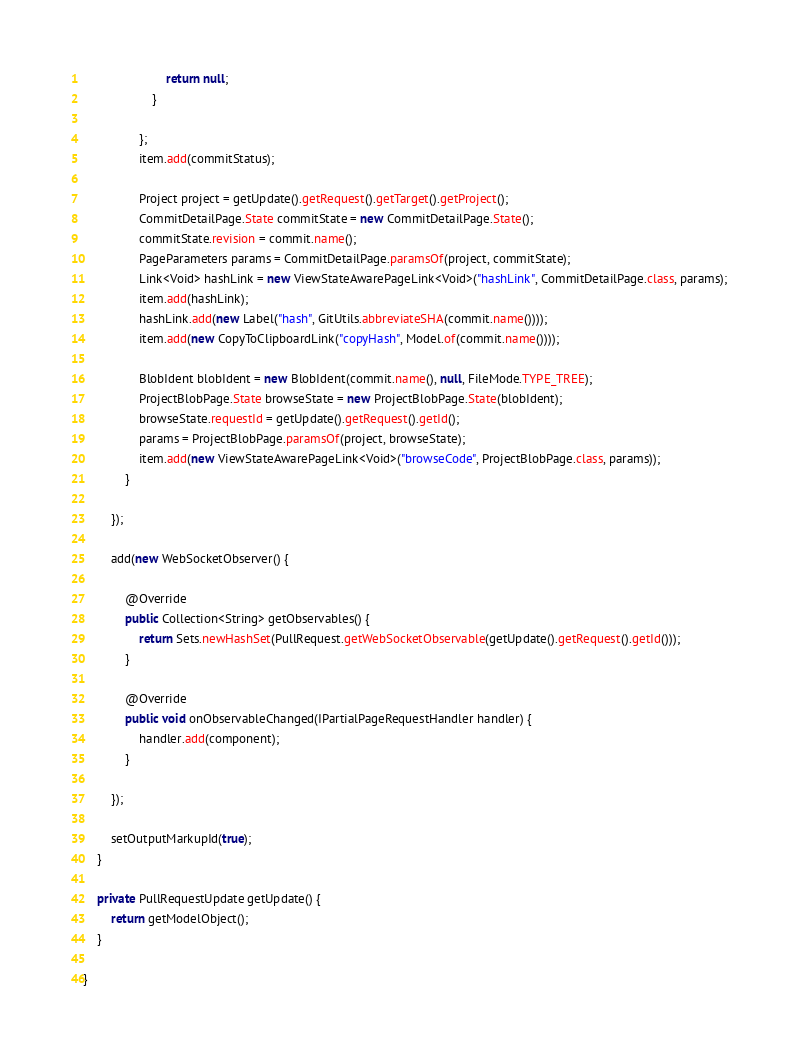<code> <loc_0><loc_0><loc_500><loc_500><_Java_>						return null;
					}
					
				};
				item.add(commitStatus);
				
				Project project = getUpdate().getRequest().getTarget().getProject();
				CommitDetailPage.State commitState = new CommitDetailPage.State();
				commitState.revision = commit.name();
				PageParameters params = CommitDetailPage.paramsOf(project, commitState);
				Link<Void> hashLink = new ViewStateAwarePageLink<Void>("hashLink", CommitDetailPage.class, params);
				item.add(hashLink);
				hashLink.add(new Label("hash", GitUtils.abbreviateSHA(commit.name())));
				item.add(new CopyToClipboardLink("copyHash", Model.of(commit.name())));

				BlobIdent blobIdent = new BlobIdent(commit.name(), null, FileMode.TYPE_TREE);
				ProjectBlobPage.State browseState = new ProjectBlobPage.State(blobIdent);
				browseState.requestId = getUpdate().getRequest().getId();
				params = ProjectBlobPage.paramsOf(project, browseState);
				item.add(new ViewStateAwarePageLink<Void>("browseCode", ProjectBlobPage.class, params));
			}
			
		});
		
		add(new WebSocketObserver() {

			@Override
			public Collection<String> getObservables() {
				return Sets.newHashSet(PullRequest.getWebSocketObservable(getUpdate().getRequest().getId()));
			}

			@Override
			public void onObservableChanged(IPartialPageRequestHandler handler) {
				handler.add(component);
			}
			
		});
		
		setOutputMarkupId(true);
	}

	private PullRequestUpdate getUpdate() {
		return getModelObject();
	}
	
}
</code> 